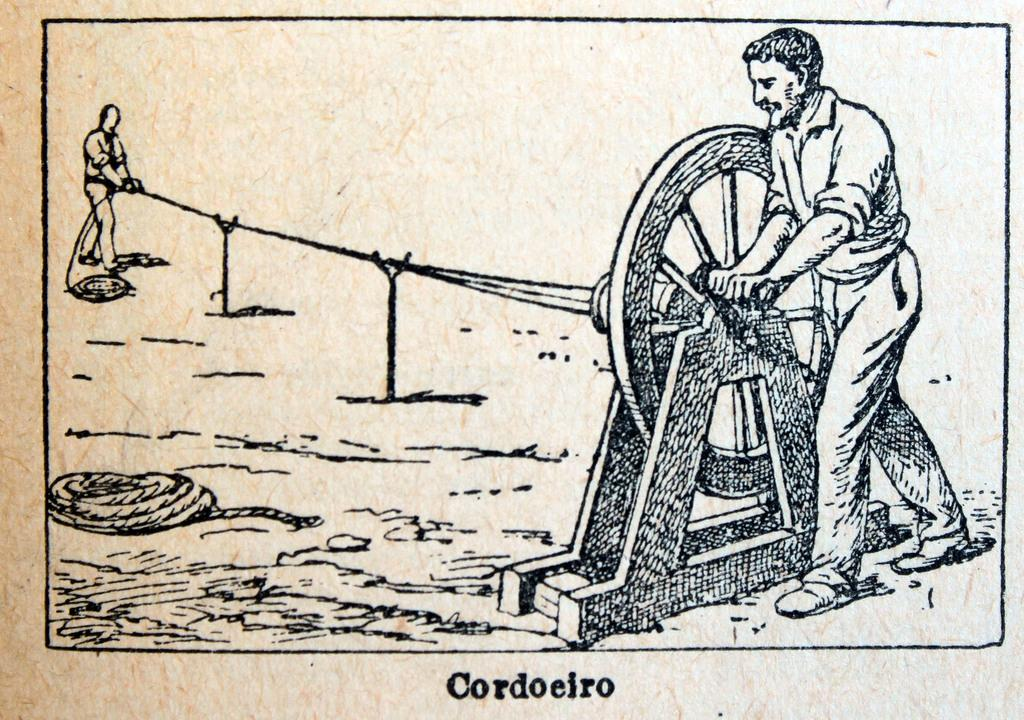What object can be seen in the image that has spokes or circular segments? There is a wheel in the image. How many people are present in the image? There are two people in the image. What is the long, flexible object in the image that can be used for pulling or tying? There is a rope in the image. Where is the shelf located in the image? There is no shelf present in the image. What type of learning is taking place in the image? There is no learning activity depicted in the image. 